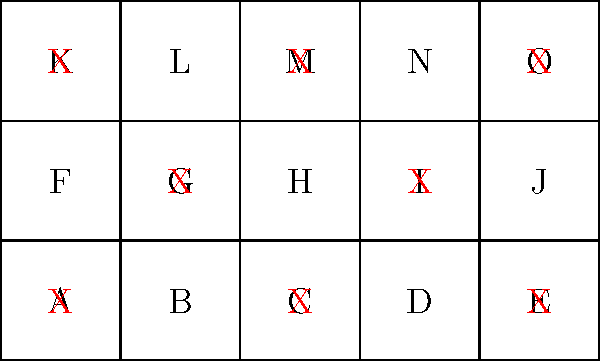As a luxury hotel chain representative, you're analyzing the occupancy rate of one of your properties. The floor plan above shows a single floor of the hotel with 15 rooms labeled A through O. Rooms marked with a red "X" are currently occupied. What is the occupancy rate of this floor, expressed as a percentage? To calculate the occupancy rate, we need to follow these steps:

1. Count the total number of rooms:
   There are 15 rooms labeled A through O.

2. Count the number of occupied rooms:
   Rooms marked with a red "X" are occupied. There are 8 such rooms.

3. Calculate the occupancy rate using the formula:
   $$ \text{Occupancy Rate} = \frac{\text{Number of Occupied Rooms}}{\text{Total Number of Rooms}} \times 100\% $$

4. Plug in the values:
   $$ \text{Occupancy Rate} = \frac{8}{15} \times 100\% $$

5. Perform the calculation:
   $$ \text{Occupancy Rate} = 0.5333... \times 100\% = 53.33...\% $$

6. Round to the nearest whole percentage:
   The occupancy rate is approximately 53%.
Answer: 53% 